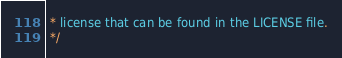Convert code to text. <code><loc_0><loc_0><loc_500><loc_500><_CSS_> * license that can be found in the LICENSE file.
 */</code> 